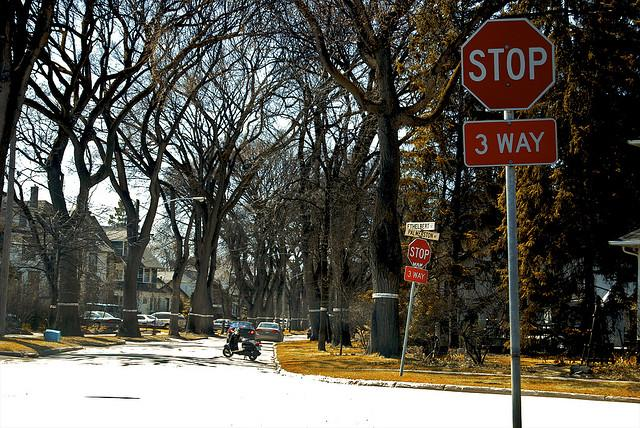How many ways are there on this stop sign?

Choices:
A) two
B) three
C) four
D) one three 